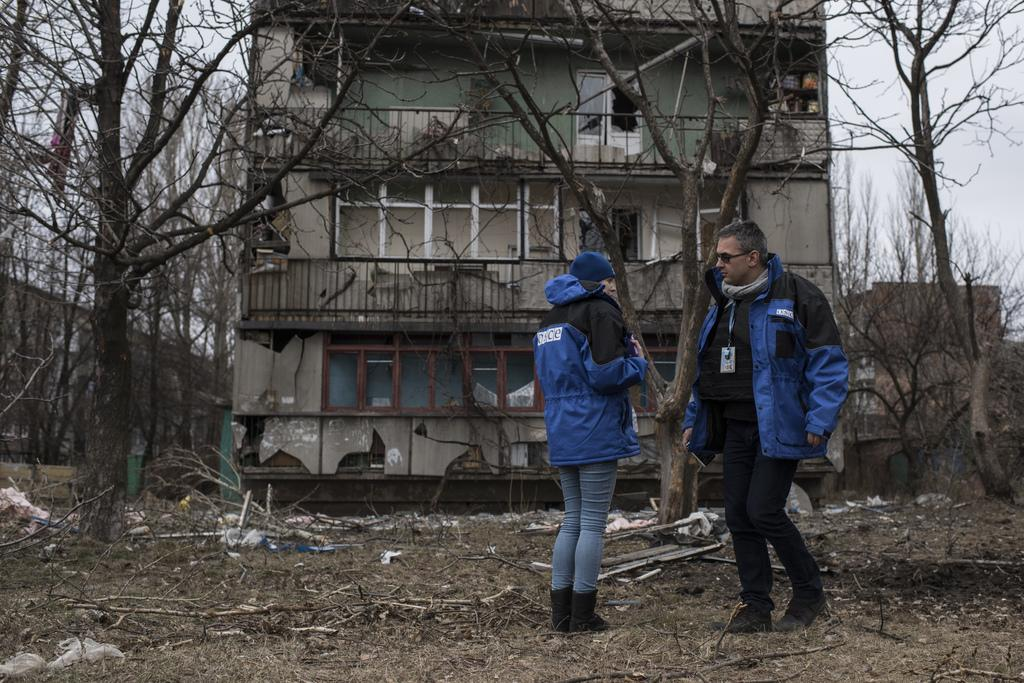What type of structure is visible in the image? There is a building in the image. What natural elements can be seen in the image? There are trees and grass on the ground in the image. Are there any people present in the image? Yes, there are people standing in the image. What is the weather like in the image? The sky is cloudy in the image. Can you describe the man in the image? There is a man wearing an ID card in the image. What else can be found on the ground in the image? There are sticks on the ground in the image. How many kittens are sitting on the seat in the image? There are no kittens or seats present in the image. What color is the shirt worn by the man in the image? The provided facts do not mention the color of the man's shirt, so we cannot answer this question. 